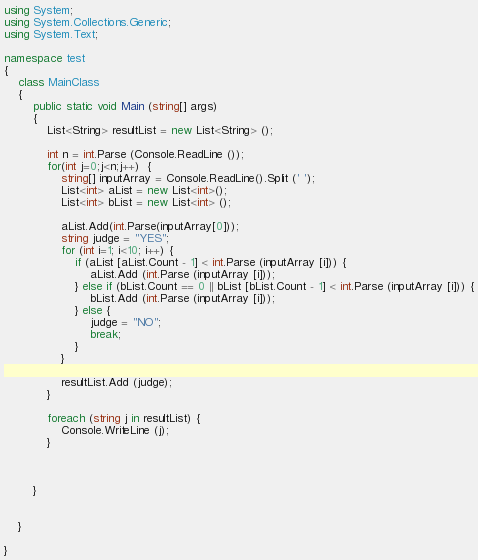Convert code to text. <code><loc_0><loc_0><loc_500><loc_500><_C#_>using System;
using System.Collections.Generic;
using System.Text;

namespace test
{
	class MainClass
	{
		public static void Main (string[] args)
		{
			List<String> resultList = new List<String> ();

			int n = int.Parse (Console.ReadLine ());
			for(int j=0;j<n;j++)  {
				string[] inputArray = Console.ReadLine().Split (' ');
				List<int> aList = new List<int>();
				List<int> bList = new List<int> ();

				aList.Add(int.Parse(inputArray[0]));
				string judge = "YES";
				for (int i=1; i<10; i++) {
					if (aList [aList.Count - 1] < int.Parse (inputArray [i])) {
						aList.Add (int.Parse (inputArray [i]));
					} else if (bList.Count == 0 || bList [bList.Count - 1] < int.Parse (inputArray [i])) {
						bList.Add (int.Parse (inputArray [i]));
					} else {
						judge = "NO";
						break;
					}
				}

				resultList.Add (judge);
			}

			foreach (string j in resultList) {
				Console.WriteLine (j);
			}



		}


	}
	
}</code> 